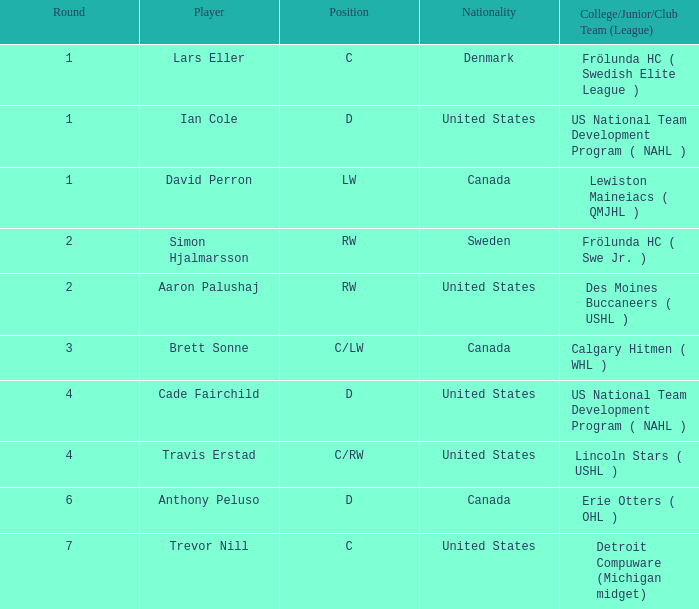Can you identify the danish player who holds the position c? Lars Eller. 